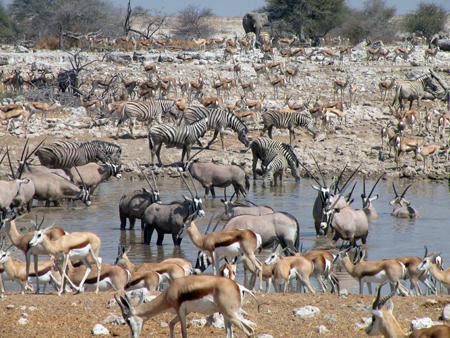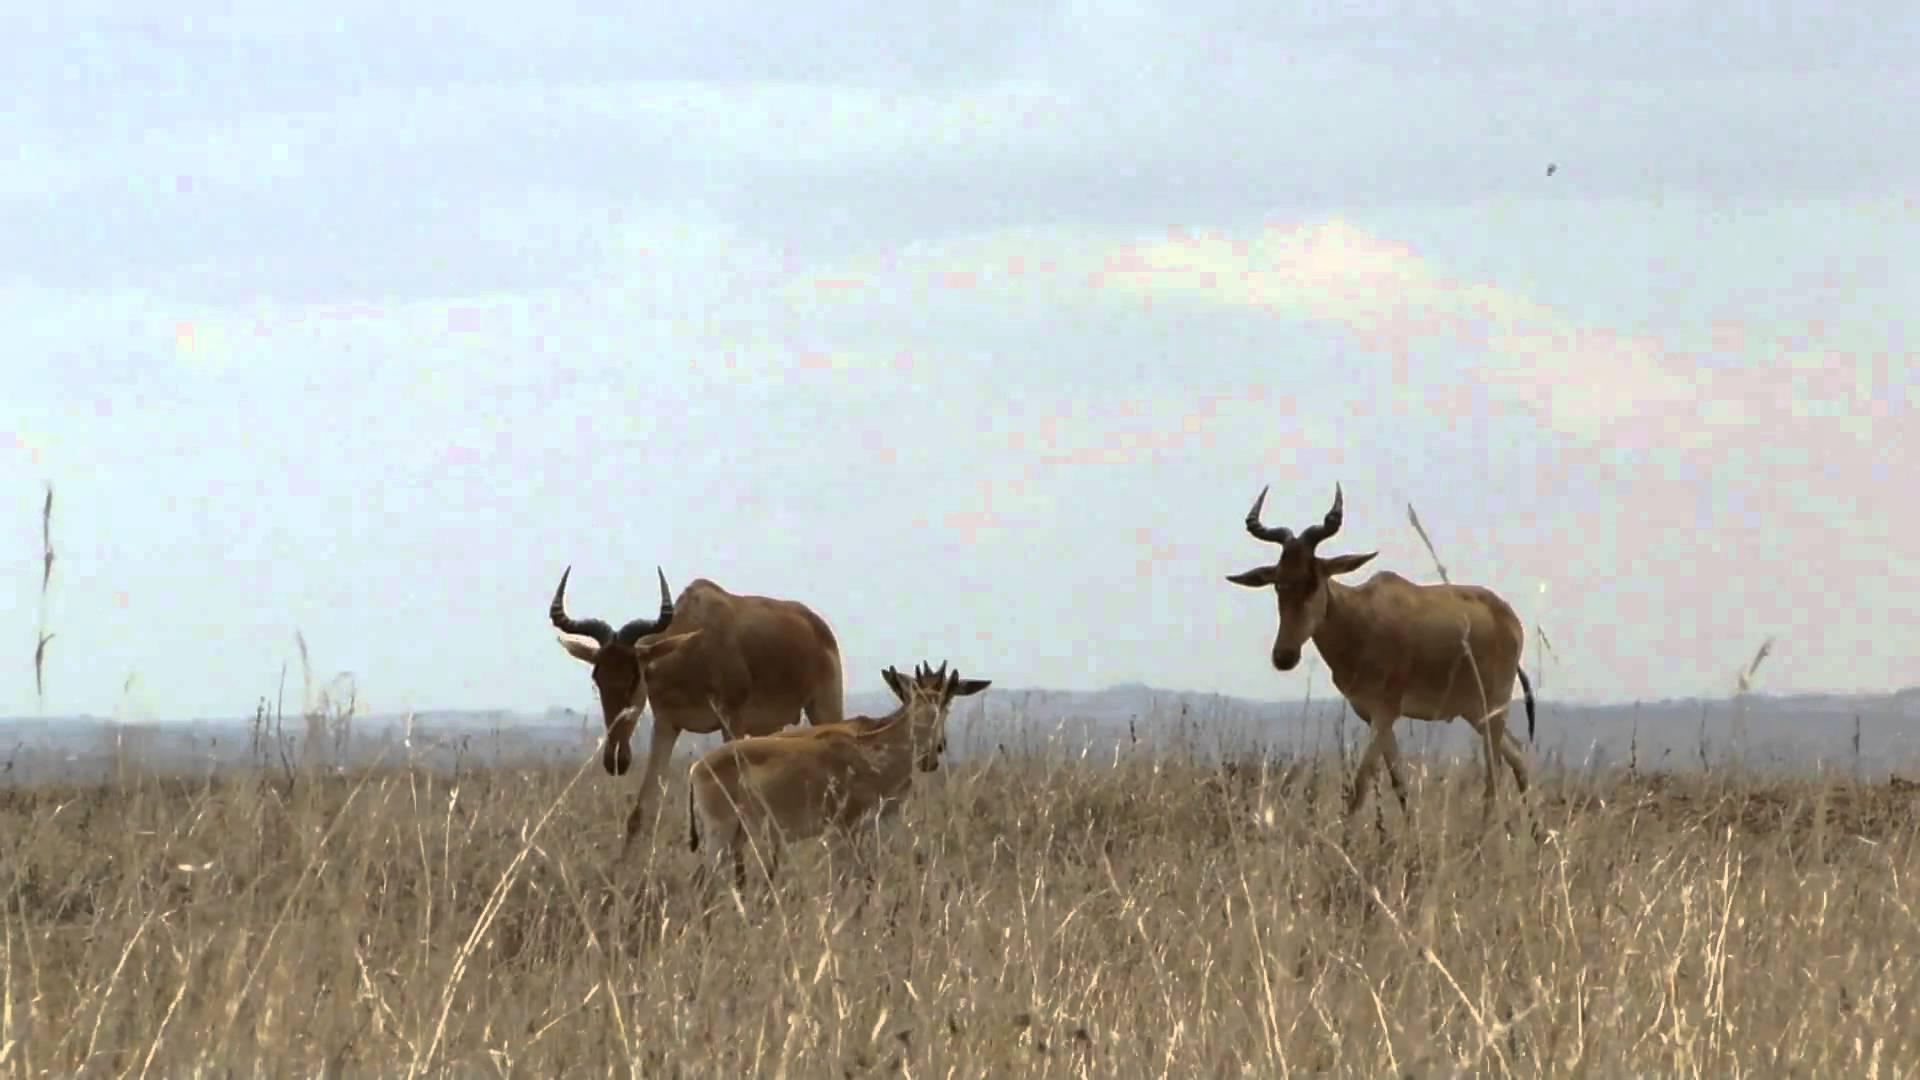The first image is the image on the left, the second image is the image on the right. Evaluate the accuracy of this statement regarding the images: "Zebra are present with horned animals in one image.". Is it true? Answer yes or no. Yes. 